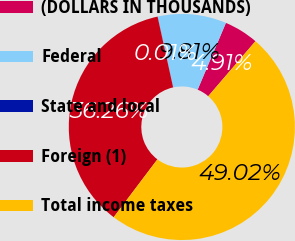Convert chart. <chart><loc_0><loc_0><loc_500><loc_500><pie_chart><fcel>(DOLLARS IN THOUSANDS)<fcel>Federal<fcel>State and local<fcel>Foreign (1)<fcel>Total income taxes<nl><fcel>4.91%<fcel>9.81%<fcel>0.01%<fcel>36.26%<fcel>49.02%<nl></chart> 